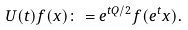Convert formula to latex. <formula><loc_0><loc_0><loc_500><loc_500>U ( t ) f ( x ) \colon = e ^ { t Q / 2 } f ( e ^ { t } x ) .</formula> 